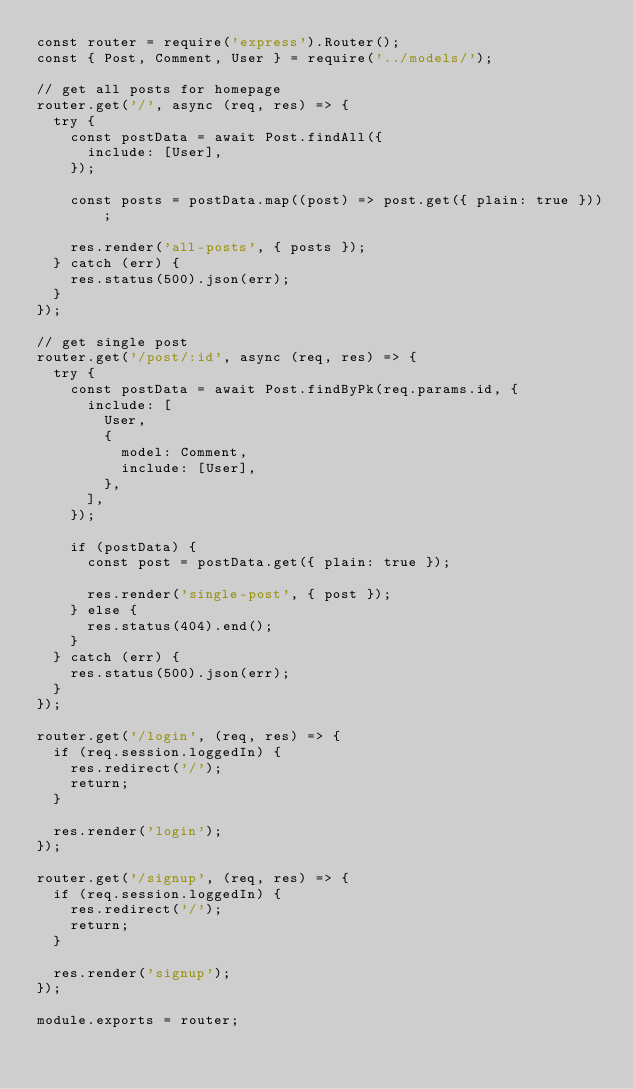<code> <loc_0><loc_0><loc_500><loc_500><_JavaScript_>const router = require('express').Router();
const { Post, Comment, User } = require('../models/');

// get all posts for homepage
router.get('/', async (req, res) => {
  try {
    const postData = await Post.findAll({
      include: [User],
    });

    const posts = postData.map((post) => post.get({ plain: true }));

    res.render('all-posts', { posts });
  } catch (err) {
    res.status(500).json(err);
  }
});

// get single post
router.get('/post/:id', async (req, res) => {
  try {
    const postData = await Post.findByPk(req.params.id, {
      include: [
        User,
        {
          model: Comment,
          include: [User],
        },
      ],
    });

    if (postData) {
      const post = postData.get({ plain: true });

      res.render('single-post', { post });
    } else {
      res.status(404).end();
    }
  } catch (err) {
    res.status(500).json(err);
  }
});

router.get('/login', (req, res) => {
  if (req.session.loggedIn) {
    res.redirect('/');
    return;
  }

  res.render('login');
});

router.get('/signup', (req, res) => {
  if (req.session.loggedIn) {
    res.redirect('/');
    return;
  }

  res.render('signup');
});

module.exports = router;
</code> 